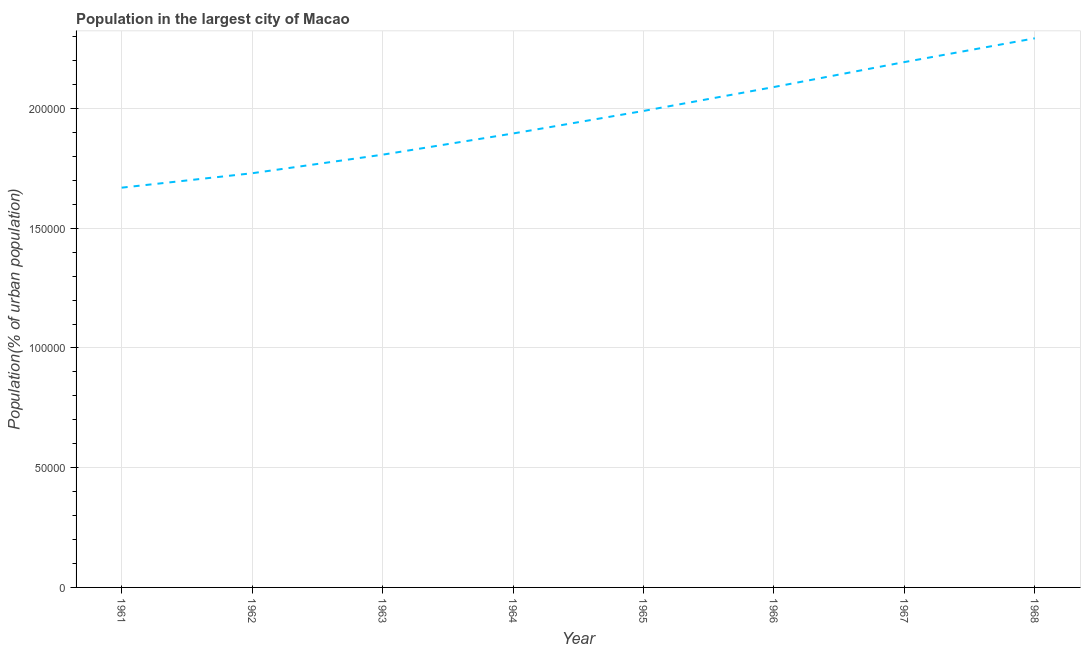What is the population in largest city in 1962?
Your response must be concise. 1.73e+05. Across all years, what is the maximum population in largest city?
Keep it short and to the point. 2.29e+05. Across all years, what is the minimum population in largest city?
Your response must be concise. 1.67e+05. In which year was the population in largest city maximum?
Make the answer very short. 1968. What is the sum of the population in largest city?
Keep it short and to the point. 1.57e+06. What is the difference between the population in largest city in 1964 and 1967?
Your answer should be compact. -2.98e+04. What is the average population in largest city per year?
Ensure brevity in your answer.  1.96e+05. What is the median population in largest city?
Provide a short and direct response. 1.94e+05. In how many years, is the population in largest city greater than 190000 %?
Your answer should be very brief. 4. What is the ratio of the population in largest city in 1963 to that in 1965?
Give a very brief answer. 0.91. Is the difference between the population in largest city in 1962 and 1963 greater than the difference between any two years?
Your answer should be very brief. No. What is the difference between the highest and the second highest population in largest city?
Offer a terse response. 9934. Is the sum of the population in largest city in 1961 and 1964 greater than the maximum population in largest city across all years?
Provide a short and direct response. Yes. What is the difference between the highest and the lowest population in largest city?
Keep it short and to the point. 6.24e+04. In how many years, is the population in largest city greater than the average population in largest city taken over all years?
Your response must be concise. 4. How many lines are there?
Your answer should be very brief. 1. What is the title of the graph?
Make the answer very short. Population in the largest city of Macao. What is the label or title of the X-axis?
Keep it short and to the point. Year. What is the label or title of the Y-axis?
Offer a very short reply. Population(% of urban population). What is the Population(% of urban population) in 1961?
Ensure brevity in your answer.  1.67e+05. What is the Population(% of urban population) in 1962?
Provide a succinct answer. 1.73e+05. What is the Population(% of urban population) of 1963?
Offer a very short reply. 1.81e+05. What is the Population(% of urban population) of 1964?
Your answer should be compact. 1.90e+05. What is the Population(% of urban population) of 1965?
Provide a short and direct response. 1.99e+05. What is the Population(% of urban population) of 1966?
Keep it short and to the point. 2.09e+05. What is the Population(% of urban population) of 1967?
Make the answer very short. 2.19e+05. What is the Population(% of urban population) of 1968?
Offer a terse response. 2.29e+05. What is the difference between the Population(% of urban population) in 1961 and 1962?
Your response must be concise. -6027. What is the difference between the Population(% of urban population) in 1961 and 1963?
Keep it short and to the point. -1.38e+04. What is the difference between the Population(% of urban population) in 1961 and 1964?
Ensure brevity in your answer.  -2.26e+04. What is the difference between the Population(% of urban population) in 1961 and 1965?
Your answer should be compact. -3.20e+04. What is the difference between the Population(% of urban population) in 1961 and 1966?
Keep it short and to the point. -4.20e+04. What is the difference between the Population(% of urban population) in 1961 and 1967?
Your response must be concise. -5.25e+04. What is the difference between the Population(% of urban population) in 1961 and 1968?
Ensure brevity in your answer.  -6.24e+04. What is the difference between the Population(% of urban population) in 1962 and 1963?
Your response must be concise. -7747. What is the difference between the Population(% of urban population) in 1962 and 1964?
Offer a terse response. -1.66e+04. What is the difference between the Population(% of urban population) in 1962 and 1965?
Your answer should be very brief. -2.60e+04. What is the difference between the Population(% of urban population) in 1962 and 1966?
Provide a succinct answer. -3.60e+04. What is the difference between the Population(% of urban population) in 1962 and 1967?
Give a very brief answer. -4.64e+04. What is the difference between the Population(% of urban population) in 1962 and 1968?
Keep it short and to the point. -5.64e+04. What is the difference between the Population(% of urban population) in 1963 and 1964?
Ensure brevity in your answer.  -8856. What is the difference between the Population(% of urban population) in 1963 and 1965?
Provide a short and direct response. -1.83e+04. What is the difference between the Population(% of urban population) in 1963 and 1966?
Provide a short and direct response. -2.83e+04. What is the difference between the Population(% of urban population) in 1963 and 1967?
Provide a succinct answer. -3.87e+04. What is the difference between the Population(% of urban population) in 1963 and 1968?
Offer a terse response. -4.86e+04. What is the difference between the Population(% of urban population) in 1964 and 1965?
Give a very brief answer. -9417. What is the difference between the Population(% of urban population) in 1964 and 1966?
Give a very brief answer. -1.94e+04. What is the difference between the Population(% of urban population) in 1964 and 1967?
Provide a succinct answer. -2.98e+04. What is the difference between the Population(% of urban population) in 1964 and 1968?
Your response must be concise. -3.98e+04. What is the difference between the Population(% of urban population) in 1965 and 1966?
Keep it short and to the point. -9990. What is the difference between the Population(% of urban population) in 1965 and 1967?
Keep it short and to the point. -2.04e+04. What is the difference between the Population(% of urban population) in 1965 and 1968?
Keep it short and to the point. -3.03e+04. What is the difference between the Population(% of urban population) in 1966 and 1967?
Your answer should be very brief. -1.04e+04. What is the difference between the Population(% of urban population) in 1966 and 1968?
Provide a short and direct response. -2.03e+04. What is the difference between the Population(% of urban population) in 1967 and 1968?
Your response must be concise. -9934. What is the ratio of the Population(% of urban population) in 1961 to that in 1962?
Your response must be concise. 0.96. What is the ratio of the Population(% of urban population) in 1961 to that in 1963?
Provide a short and direct response. 0.92. What is the ratio of the Population(% of urban population) in 1961 to that in 1964?
Your response must be concise. 0.88. What is the ratio of the Population(% of urban population) in 1961 to that in 1965?
Ensure brevity in your answer.  0.84. What is the ratio of the Population(% of urban population) in 1961 to that in 1966?
Offer a terse response. 0.8. What is the ratio of the Population(% of urban population) in 1961 to that in 1967?
Your answer should be compact. 0.76. What is the ratio of the Population(% of urban population) in 1961 to that in 1968?
Offer a terse response. 0.73. What is the ratio of the Population(% of urban population) in 1962 to that in 1963?
Ensure brevity in your answer.  0.96. What is the ratio of the Population(% of urban population) in 1962 to that in 1964?
Provide a short and direct response. 0.91. What is the ratio of the Population(% of urban population) in 1962 to that in 1965?
Make the answer very short. 0.87. What is the ratio of the Population(% of urban population) in 1962 to that in 1966?
Ensure brevity in your answer.  0.83. What is the ratio of the Population(% of urban population) in 1962 to that in 1967?
Make the answer very short. 0.79. What is the ratio of the Population(% of urban population) in 1962 to that in 1968?
Provide a succinct answer. 0.75. What is the ratio of the Population(% of urban population) in 1963 to that in 1964?
Make the answer very short. 0.95. What is the ratio of the Population(% of urban population) in 1963 to that in 1965?
Give a very brief answer. 0.91. What is the ratio of the Population(% of urban population) in 1963 to that in 1966?
Your response must be concise. 0.86. What is the ratio of the Population(% of urban population) in 1963 to that in 1967?
Offer a terse response. 0.82. What is the ratio of the Population(% of urban population) in 1963 to that in 1968?
Your answer should be compact. 0.79. What is the ratio of the Population(% of urban population) in 1964 to that in 1965?
Your response must be concise. 0.95. What is the ratio of the Population(% of urban population) in 1964 to that in 1966?
Provide a succinct answer. 0.91. What is the ratio of the Population(% of urban population) in 1964 to that in 1967?
Ensure brevity in your answer.  0.86. What is the ratio of the Population(% of urban population) in 1964 to that in 1968?
Your answer should be compact. 0.83. What is the ratio of the Population(% of urban population) in 1965 to that in 1966?
Keep it short and to the point. 0.95. What is the ratio of the Population(% of urban population) in 1965 to that in 1967?
Your answer should be compact. 0.91. What is the ratio of the Population(% of urban population) in 1965 to that in 1968?
Your response must be concise. 0.87. What is the ratio of the Population(% of urban population) in 1966 to that in 1967?
Your answer should be compact. 0.95. What is the ratio of the Population(% of urban population) in 1966 to that in 1968?
Make the answer very short. 0.91. 